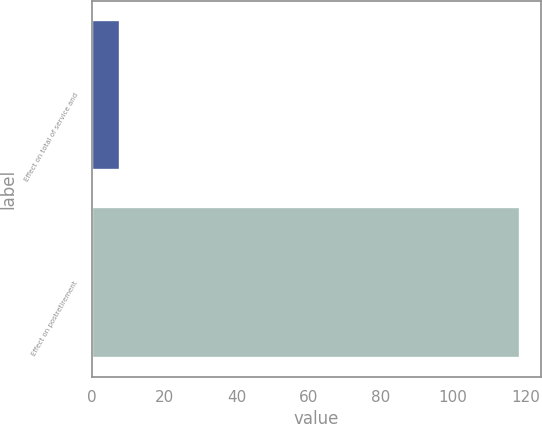Convert chart to OTSL. <chart><loc_0><loc_0><loc_500><loc_500><bar_chart><fcel>Effect on total of service and<fcel>Effect on postretirement<nl><fcel>7.7<fcel>118.4<nl></chart> 